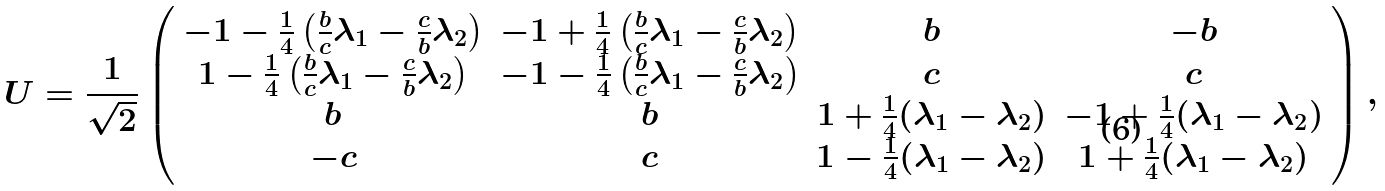<formula> <loc_0><loc_0><loc_500><loc_500>U = \frac { 1 } { \sqrt { 2 } } \left ( \begin{array} { c c c c } - 1 - \frac { 1 } { 4 } \left ( \frac { b } { c } \lambda _ { 1 } - \frac { c } { b } \lambda _ { 2 } \right ) & - 1 + \frac { 1 } { 4 } \left ( \frac { b } { c } \lambda _ { 1 } - \frac { c } { b } \lambda _ { 2 } \right ) & b & - b \\ 1 - \frac { 1 } { 4 } \left ( \frac { b } { c } \lambda _ { 1 } - \frac { c } { b } \lambda _ { 2 } \right ) & - 1 - \frac { 1 } { 4 } \left ( \frac { b } { c } \lambda _ { 1 } - \frac { c } { b } \lambda _ { 2 } \right ) & c & c \\ b & b & 1 + \frac { 1 } { 4 } ( \lambda _ { 1 } - \lambda _ { 2 } ) & - 1 + \frac { 1 } { 4 } ( \lambda _ { 1 } - \lambda _ { 2 } ) \\ - c & c & 1 - \frac { 1 } { 4 } ( \lambda _ { 1 } - \lambda _ { 2 } ) & 1 + \frac { 1 } { 4 } ( \lambda _ { 1 } - \lambda _ { 2 } ) \end{array} \right ) ,</formula> 